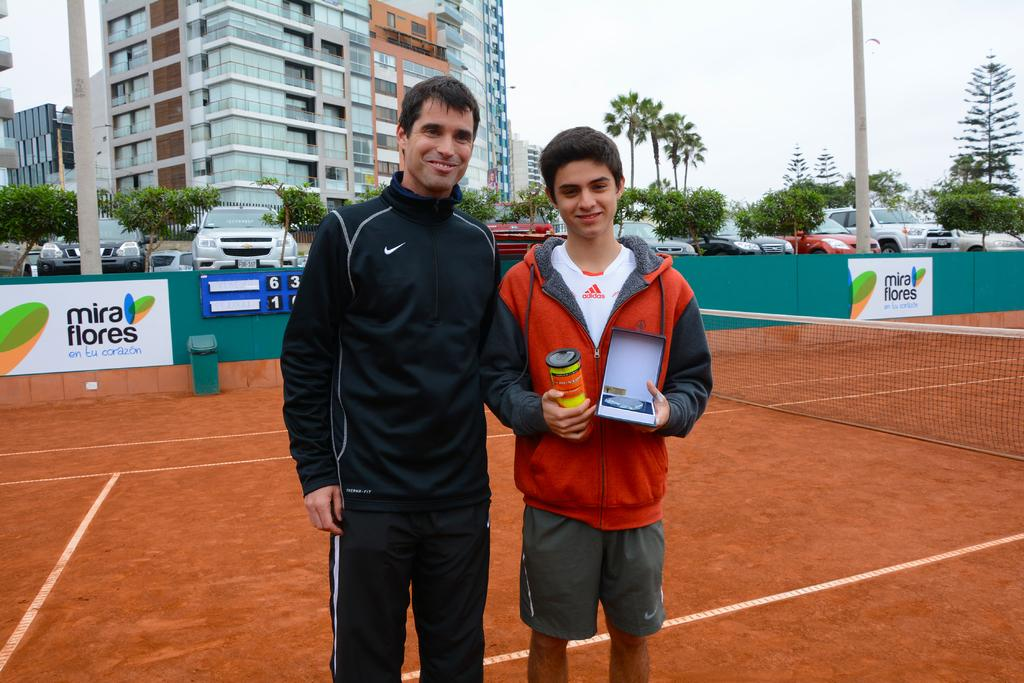What activity are the two people engaged in within the image? The two people are standing in a tennis court, which suggests they might be playing tennis or waiting for their turn. What can be seen in the background of the image? There are buildings, trees, and cars in the background of the image. What other objects are present in the image? There are electric poles in the image. What is visible in the sky in the image? The sky is visible in the image. Can you tell me how many rats are sitting on the plate in the image? There are no rats or plates present in the image. What type of knee injury is visible on one of the tennis players in the image? There is no indication of any knee injuries or medical conditions in the image. 